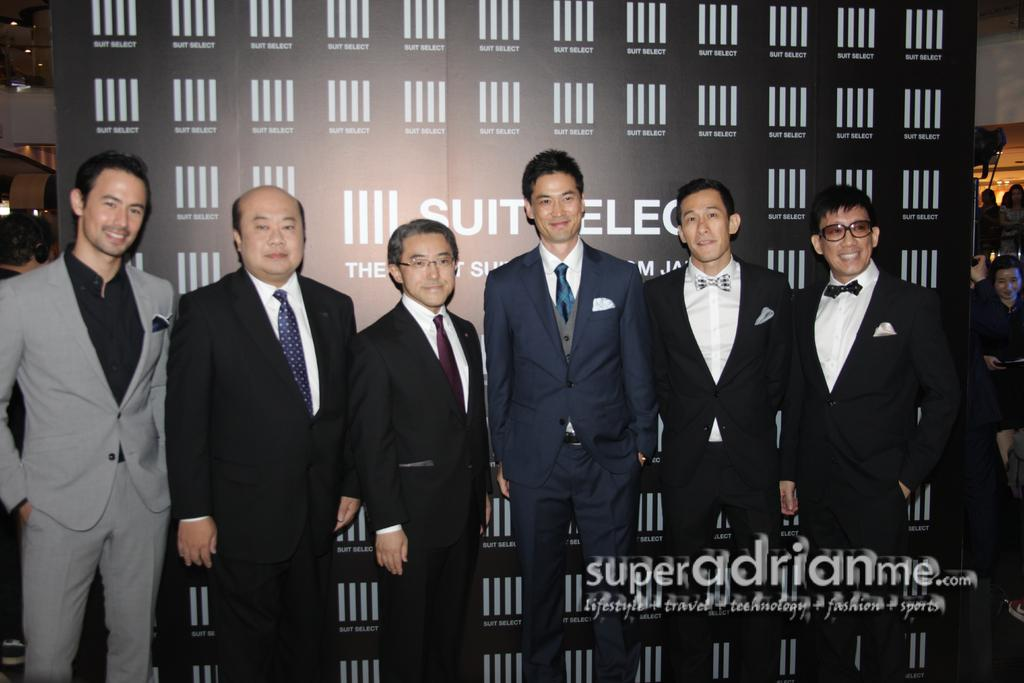How many men are in the foreground of the image? There are seven men in suits in the foreground of the image. What are the men standing in front of? The men are standing in front of a banner. What expressions do the men have? The men are smiling. Can you describe the background of the image? There are persons in the background of the image. What type of soup is being served in the image? There is no soup present in the image. Can you describe the pickle that is being held by one of the men? There is no pickle visible in the image; the men are not holding any pickles. 